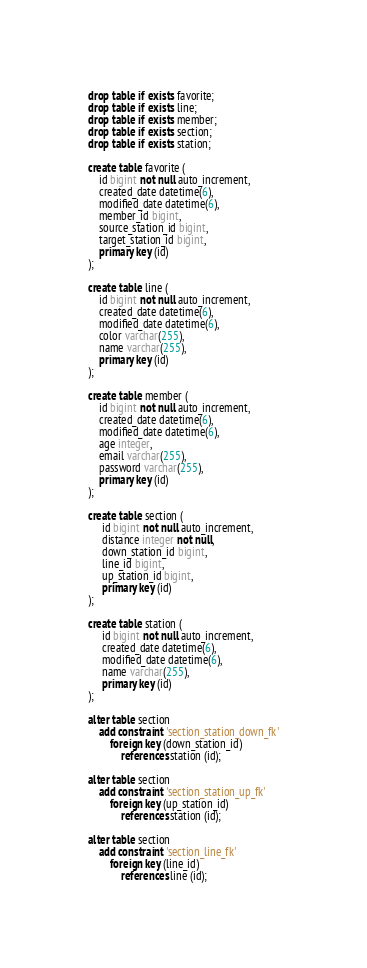<code> <loc_0><loc_0><loc_500><loc_500><_SQL_>drop table if exists favorite;
drop table if exists line;
drop table if exists member;
drop table if exists section;
drop table if exists station;

create table favorite (
    id bigint not null auto_increment,
    created_date datetime(6),
    modified_date datetime(6),
    member_id bigint,
    source_station_id bigint,
    target_station_id bigint,
    primary key (id)
);

create table line (
    id bigint not null auto_increment,
    created_date datetime(6),
    modified_date datetime(6),
    color varchar(255),
    name varchar(255),
    primary key (id)
);

create table member (
    id bigint not null auto_increment,
    created_date datetime(6),
    modified_date datetime(6),
    age integer,
    email varchar(255),
    password varchar(255),
    primary key (id)
);

create table section (
     id bigint not null auto_increment,
     distance integer not null,
     down_station_id bigint,
     line_id bigint,
     up_station_id bigint,
     primary key (id)
);

create table station (
     id bigint not null auto_increment,
     created_date datetime(6),
     modified_date datetime(6),
     name varchar(255),
     primary key (id)
);

alter table section
    add constraint 'section_station_down_fk'
        foreign key (down_station_id)
            references station (id);

alter table section
    add constraint 'section_station_up_fk'
        foreign key (up_station_id)
            references station (id);

alter table section
    add constraint 'section_line_fk'
        foreign key (line_id)
            references line (id);</code> 